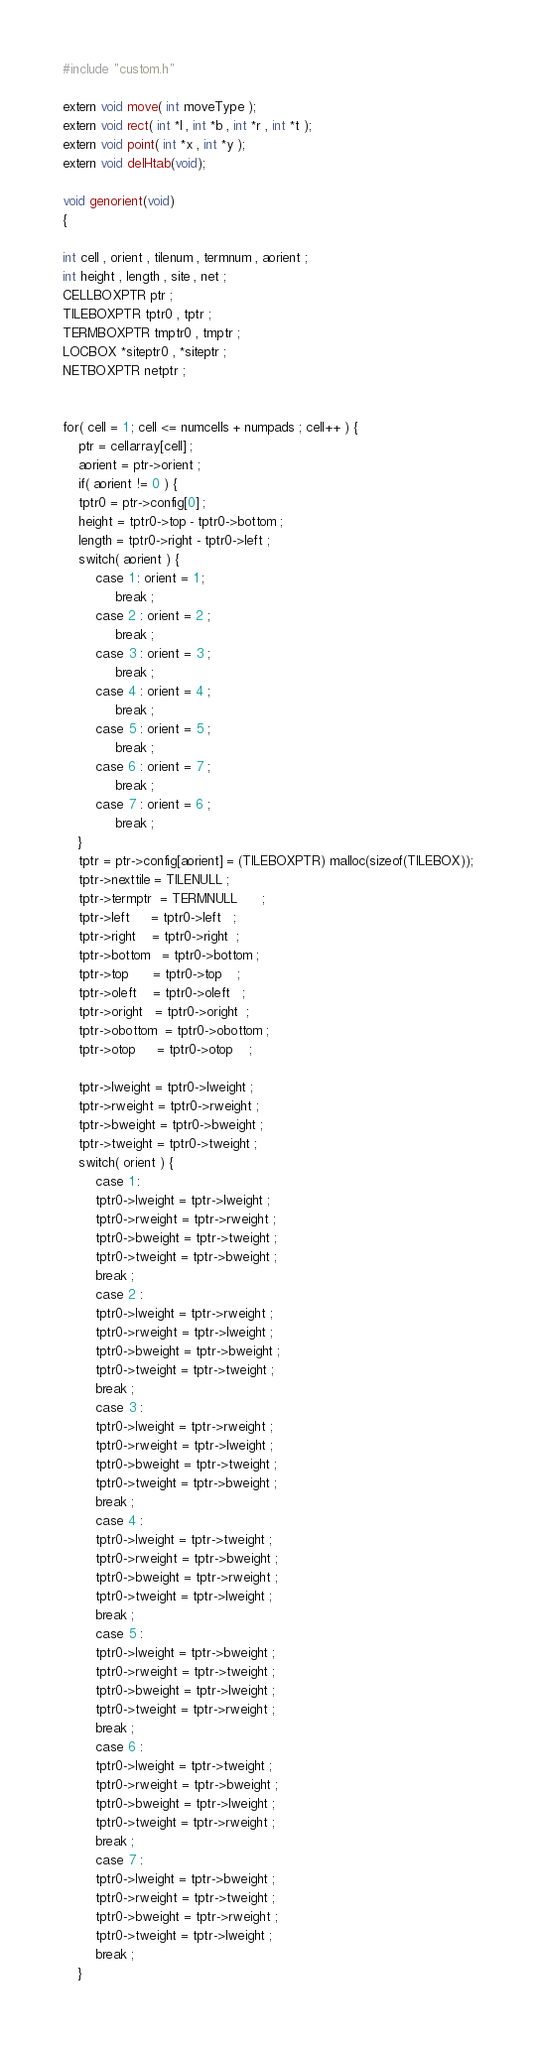Convert code to text. <code><loc_0><loc_0><loc_500><loc_500><_C_>#include "custom.h"

extern void move( int moveType );
extern void rect( int *l , int *b , int *r , int *t );
extern void point( int *x , int *y );
extern void delHtab(void);

void genorient(void)
{

int cell , orient , tilenum , termnum , aorient ;
int height , length , site , net ;
CELLBOXPTR ptr ;
TILEBOXPTR tptr0 , tptr ;
TERMBOXPTR tmptr0 , tmptr ;
LOCBOX *siteptr0 , *siteptr ;
NETBOXPTR netptr ;


for( cell = 1 ; cell <= numcells + numpads ; cell++ ) {
    ptr = cellarray[cell] ;
    aorient = ptr->orient ;
    if( aorient != 0 ) {
	tptr0 = ptr->config[0] ;
	height = tptr0->top - tptr0->bottom ;
	length = tptr0->right - tptr0->left ;
	switch( aorient ) {
	    case 1 : orient = 1 ;
		     break ;
	    case 2 : orient = 2 ;
		     break ;
	    case 3 : orient = 3 ;
		     break ;
	    case 4 : orient = 4 ;
		     break ;
	    case 5 : orient = 5 ;
		     break ;
	    case 6 : orient = 7 ;
		     break ;
	    case 7 : orient = 6 ;
		     break ;
	}
	tptr = ptr->config[aorient] = (TILEBOXPTR) malloc(sizeof(TILEBOX));
	tptr->nexttile = TILENULL ;
	tptr->termptr  = TERMNULL      ;
	tptr->left     = tptr0->left   ;
	tptr->right    = tptr0->right  ;
	tptr->bottom   = tptr0->bottom ;
	tptr->top      = tptr0->top    ;
	tptr->oleft    = tptr0->oleft   ;
	tptr->oright   = tptr0->oright  ;
	tptr->obottom  = tptr0->obottom ;
	tptr->otop     = tptr0->otop    ;

	tptr->lweight = tptr0->lweight ;
	tptr->rweight = tptr0->rweight ;
	tptr->bweight = tptr0->bweight ;
	tptr->tweight = tptr0->tweight ;
	switch( orient ) {
	    case 1 :  
		tptr0->lweight = tptr->lweight ;
		tptr0->rweight = tptr->rweight ;
		tptr0->bweight = tptr->tweight ;
		tptr0->tweight = tptr->bweight ;
		break ;
	    case 2 :
		tptr0->lweight = tptr->rweight ;
		tptr0->rweight = tptr->lweight ;
		tptr0->bweight = tptr->bweight ;
		tptr0->tweight = tptr->tweight ;
		break ;
	    case 3 :
		tptr0->lweight = tptr->rweight ;
		tptr0->rweight = tptr->lweight ;
		tptr0->bweight = tptr->tweight ;
		tptr0->tweight = tptr->bweight ;
		break ;
	    case 4 :
		tptr0->lweight = tptr->tweight ;
		tptr0->rweight = tptr->bweight ;
		tptr0->bweight = tptr->rweight ;
		tptr0->tweight = tptr->lweight ;
		break ;
	    case 5 :
		tptr0->lweight = tptr->bweight ;
		tptr0->rweight = tptr->tweight ;
		tptr0->bweight = tptr->lweight ;
		tptr0->tweight = tptr->rweight ;
		break ;
	    case 6 :
		tptr0->lweight = tptr->tweight ;
		tptr0->rweight = tptr->bweight ;
		tptr0->bweight = tptr->lweight ;
		tptr0->tweight = tptr->rweight ;
		break ;
	    case 7 :
		tptr0->lweight = tptr->bweight ;
		tptr0->rweight = tptr->tweight ;
		tptr0->bweight = tptr->rweight ;
		tptr0->tweight = tptr->lweight ;
		break ;
	}
</code> 